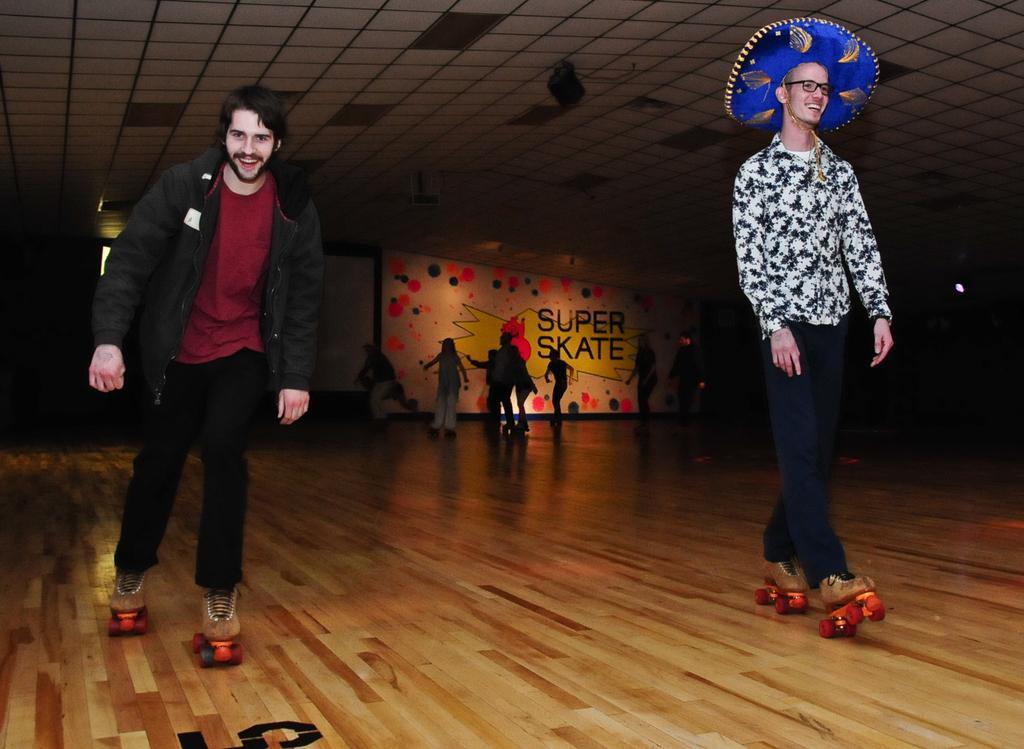In one or two sentences, can you explain what this image depicts? In this image we can see people skating on the floor. In the background there is a board and we can see lights. 